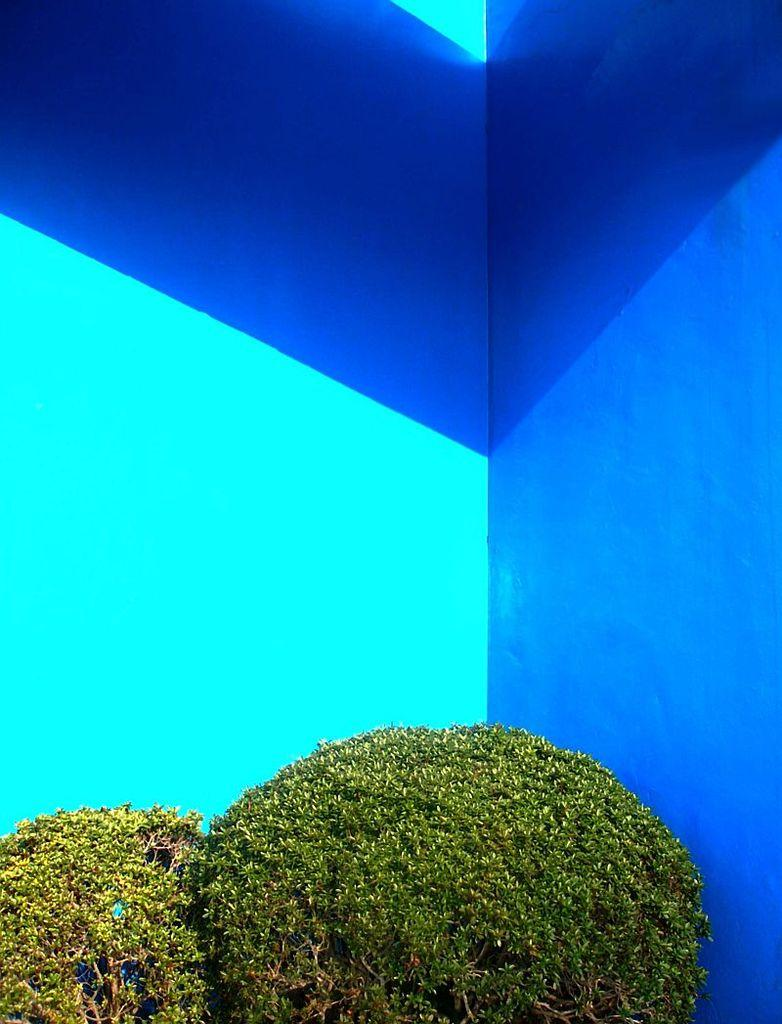What type of vegetation can be seen in the image? There are shrubs in the image. What is visible in the background of the image? There is a wall visible in the background of the image. What type of example can be seen hanging from the shrubs in the image? There is no example hanging from the shrubs in the image. What type of grape can be seen growing on the wall in the image? There is no grape growing on the wall in the image. 